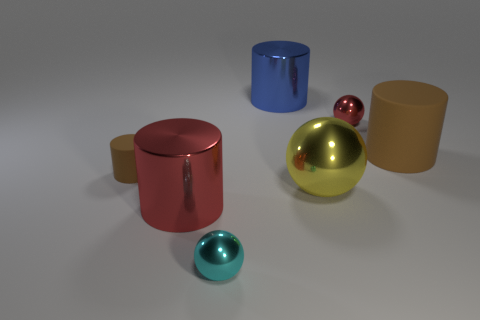Is there a big metallic cylinder that is to the right of the brown cylinder that is to the right of the red object that is behind the large brown matte thing?
Keep it short and to the point. No. What is the small cyan object made of?
Offer a very short reply. Metal. How many other things are the same shape as the cyan metallic thing?
Keep it short and to the point. 2. Do the yellow object and the small red metal thing have the same shape?
Offer a terse response. Yes. How many objects are things in front of the red metallic cylinder or brown matte things that are on the left side of the large blue cylinder?
Make the answer very short. 2. How many things are large red cylinders or large blue things?
Ensure brevity in your answer.  2. There is a brown cylinder left of the large brown rubber thing; what number of tiny brown matte cylinders are in front of it?
Provide a succinct answer. 0. What number of other things are the same size as the red metallic sphere?
Offer a very short reply. 2. The object that is the same color as the large matte cylinder is what size?
Make the answer very short. Small. There is a small object that is in front of the small matte thing; is it the same shape as the blue object?
Offer a terse response. No. 